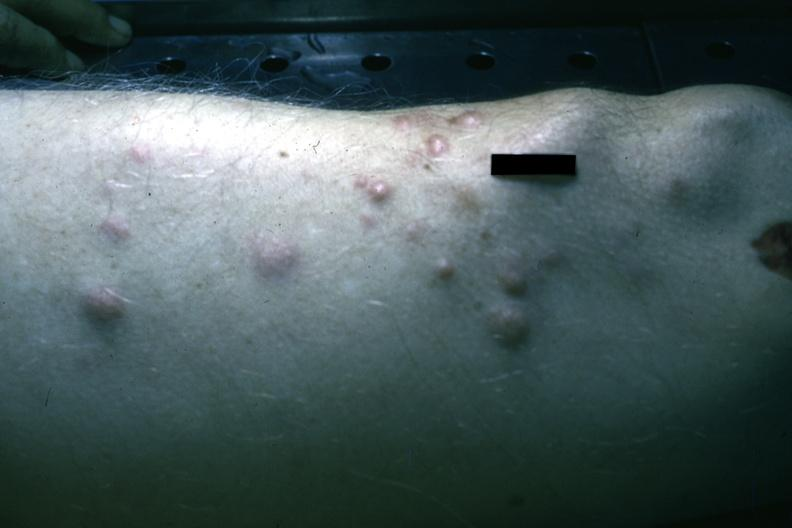s multiple myeloma present?
Answer the question using a single word or phrase. Yes 